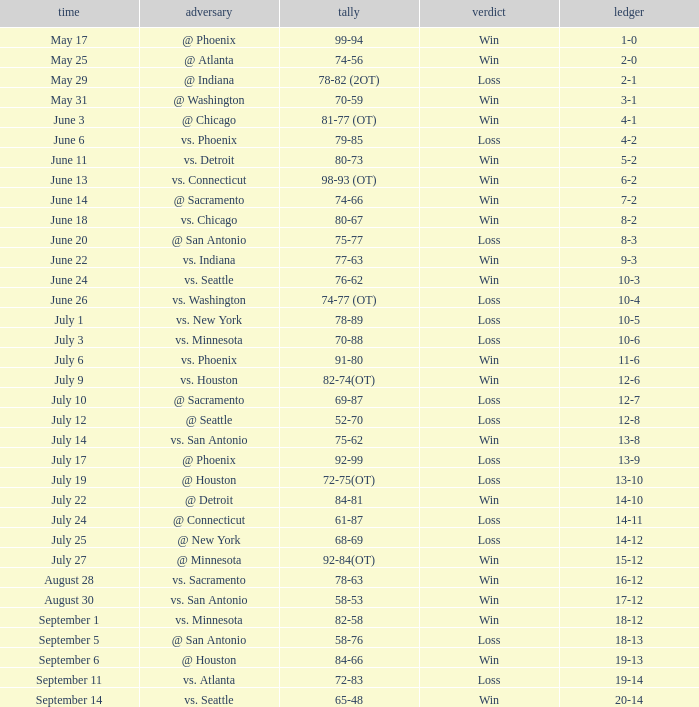What is the Record of the game on September 6? 19-13. Help me parse the entirety of this table. {'header': ['time', 'adversary', 'tally', 'verdict', 'ledger'], 'rows': [['May 17', '@ Phoenix', '99-94', 'Win', '1-0'], ['May 25', '@ Atlanta', '74-56', 'Win', '2-0'], ['May 29', '@ Indiana', '78-82 (2OT)', 'Loss', '2-1'], ['May 31', '@ Washington', '70-59', 'Win', '3-1'], ['June 3', '@ Chicago', '81-77 (OT)', 'Win', '4-1'], ['June 6', 'vs. Phoenix', '79-85', 'Loss', '4-2'], ['June 11', 'vs. Detroit', '80-73', 'Win', '5-2'], ['June 13', 'vs. Connecticut', '98-93 (OT)', 'Win', '6-2'], ['June 14', '@ Sacramento', '74-66', 'Win', '7-2'], ['June 18', 'vs. Chicago', '80-67', 'Win', '8-2'], ['June 20', '@ San Antonio', '75-77', 'Loss', '8-3'], ['June 22', 'vs. Indiana', '77-63', 'Win', '9-3'], ['June 24', 'vs. Seattle', '76-62', 'Win', '10-3'], ['June 26', 'vs. Washington', '74-77 (OT)', 'Loss', '10-4'], ['July 1', 'vs. New York', '78-89', 'Loss', '10-5'], ['July 3', 'vs. Minnesota', '70-88', 'Loss', '10-6'], ['July 6', 'vs. Phoenix', '91-80', 'Win', '11-6'], ['July 9', 'vs. Houston', '82-74(OT)', 'Win', '12-6'], ['July 10', '@ Sacramento', '69-87', 'Loss', '12-7'], ['July 12', '@ Seattle', '52-70', 'Loss', '12-8'], ['July 14', 'vs. San Antonio', '75-62', 'Win', '13-8'], ['July 17', '@ Phoenix', '92-99', 'Loss', '13-9'], ['July 19', '@ Houston', '72-75(OT)', 'Loss', '13-10'], ['July 22', '@ Detroit', '84-81', 'Win', '14-10'], ['July 24', '@ Connecticut', '61-87', 'Loss', '14-11'], ['July 25', '@ New York', '68-69', 'Loss', '14-12'], ['July 27', '@ Minnesota', '92-84(OT)', 'Win', '15-12'], ['August 28', 'vs. Sacramento', '78-63', 'Win', '16-12'], ['August 30', 'vs. San Antonio', '58-53', 'Win', '17-12'], ['September 1', 'vs. Minnesota', '82-58', 'Win', '18-12'], ['September 5', '@ San Antonio', '58-76', 'Loss', '18-13'], ['September 6', '@ Houston', '84-66', 'Win', '19-13'], ['September 11', 'vs. Atlanta', '72-83', 'Loss', '19-14'], ['September 14', 'vs. Seattle', '65-48', 'Win', '20-14']]} 